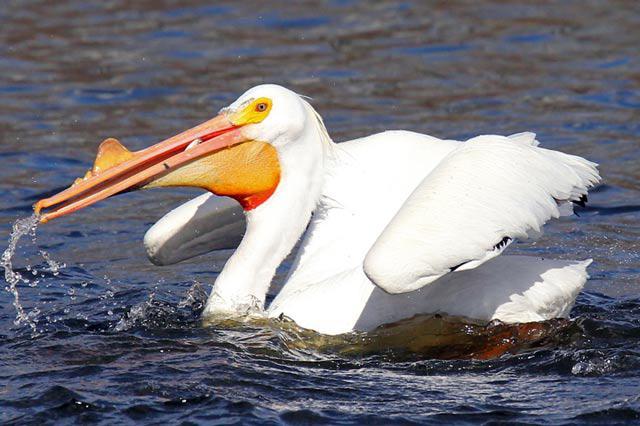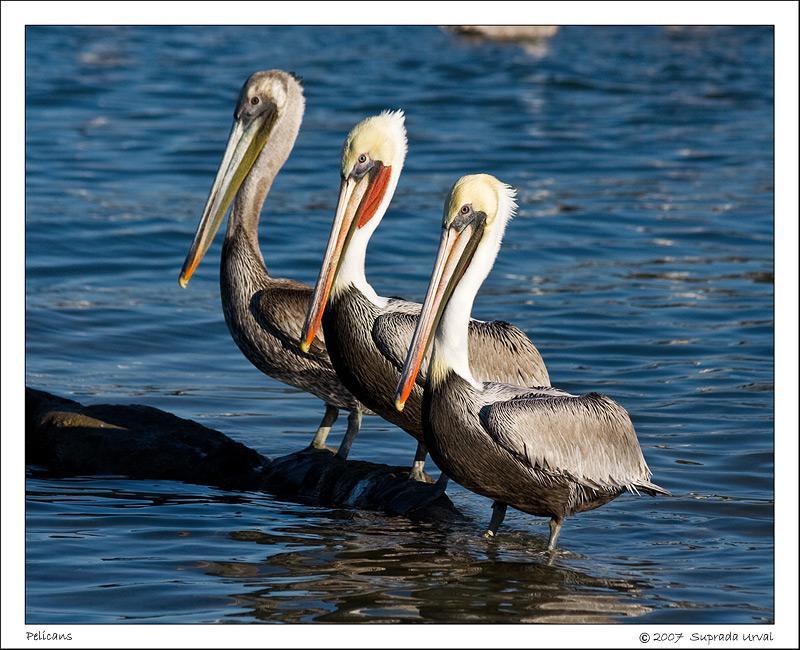The first image is the image on the left, the second image is the image on the right. Considering the images on both sides, is "At least 6 pelicans face left." valid? Answer yes or no. No. The first image is the image on the left, the second image is the image on the right. Evaluate the accuracy of this statement regarding the images: "In one of the image there is a pelican in the water.". Is it true? Answer yes or no. Yes. 